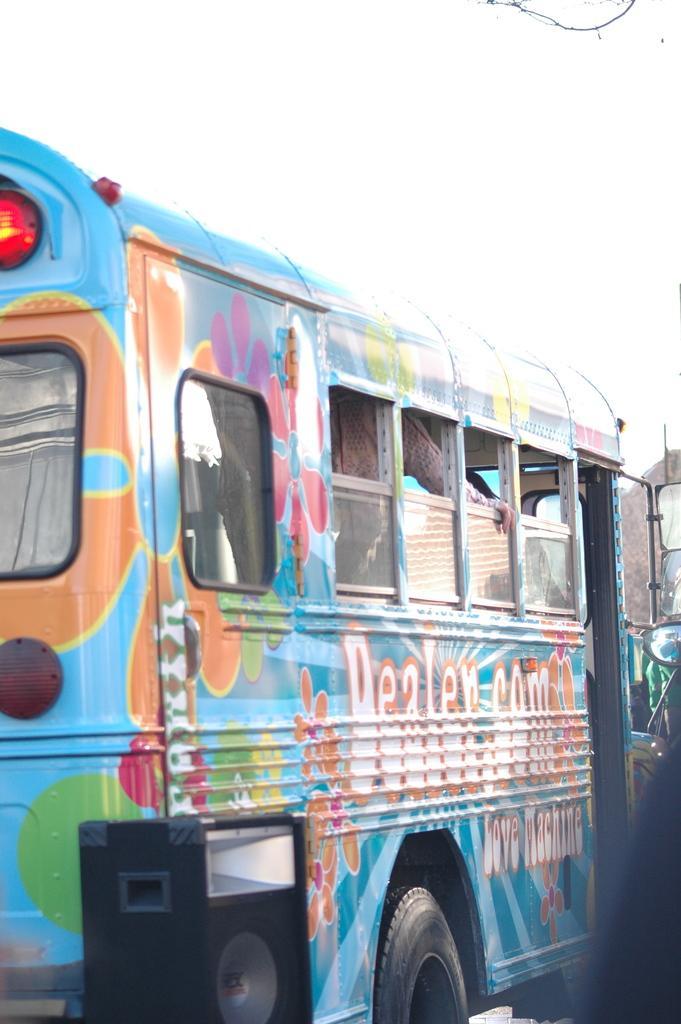How would you summarize this image in a sentence or two? In the image we can see a vehicle, sound box and the sky. In the vehicle we can see a person wearing clothes. 